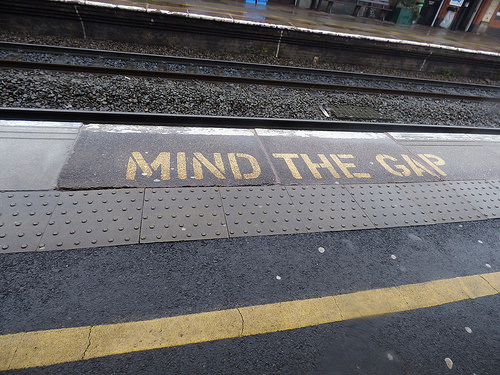<image>
Is the sign under the rail? No. The sign is not positioned under the rail. The vertical relationship between these objects is different. 